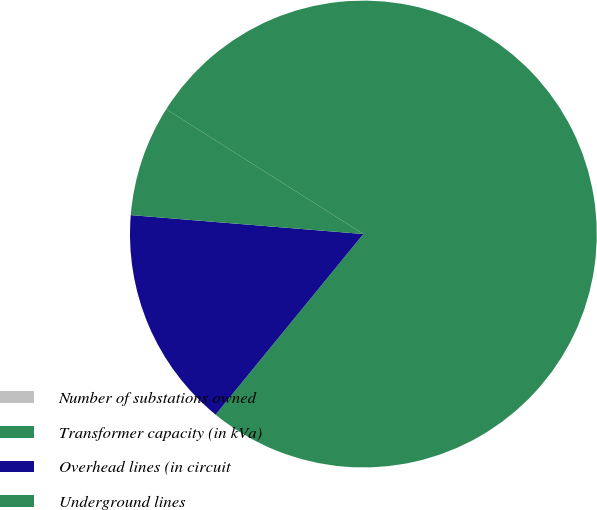<chart> <loc_0><loc_0><loc_500><loc_500><pie_chart><fcel>Number of substations owned<fcel>Transformer capacity (in kVa)<fcel>Overhead lines (in circuit<fcel>Underground lines<nl><fcel>0.0%<fcel>76.92%<fcel>15.38%<fcel>7.69%<nl></chart> 